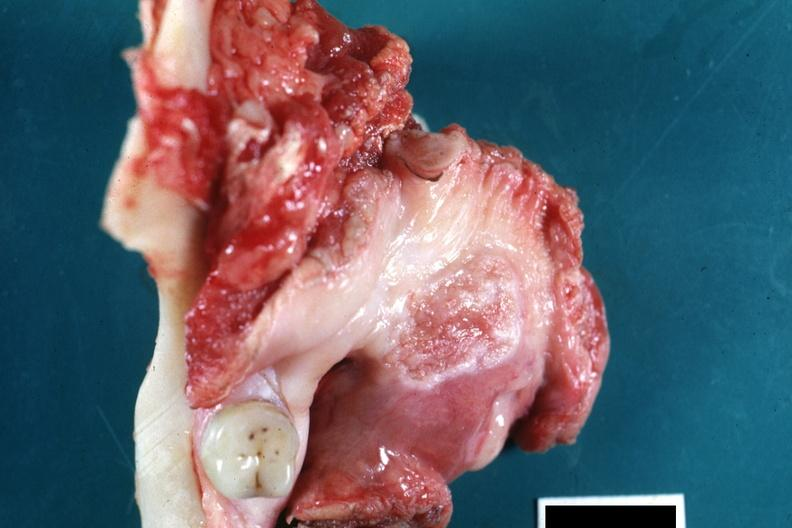what does this image show?
Answer the question using a single word or phrase. Surgical specimen with molar tooth large ulcerating carcinoma on hard palate excellent example -66 